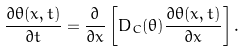<formula> <loc_0><loc_0><loc_500><loc_500>\frac { \partial \theta ( x , t ) } { \partial t } = \frac { \partial } { \partial x } \left [ D _ { C } ( \theta ) \frac { \partial \theta ( x , t ) } { \partial x } \right ] .</formula> 